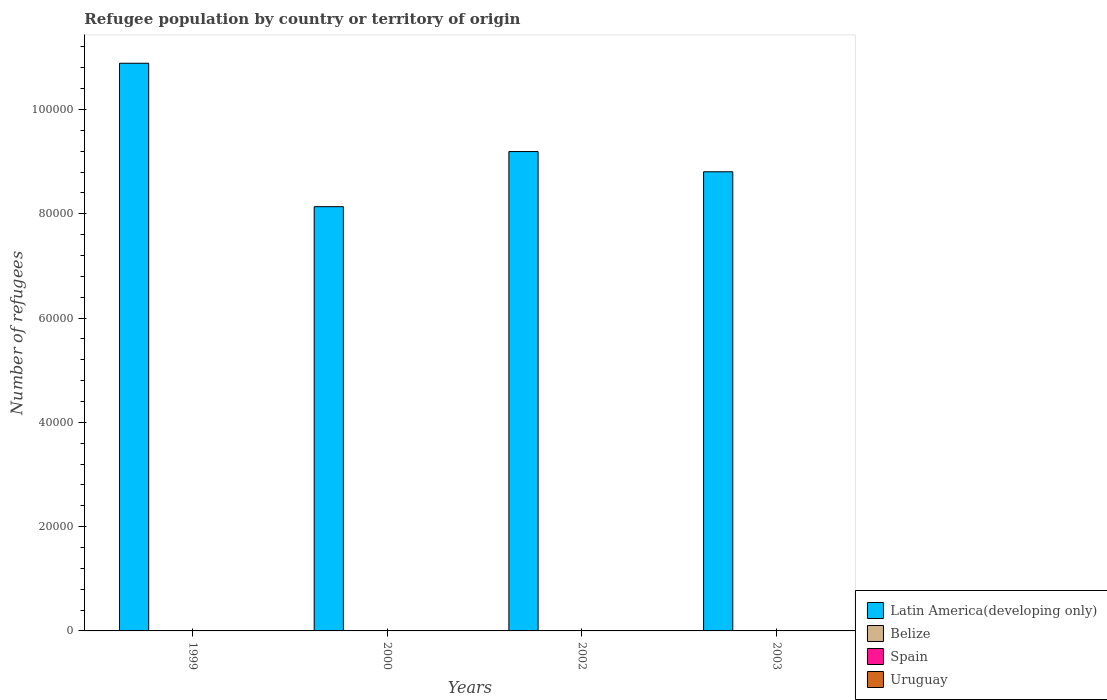Are the number of bars on each tick of the X-axis equal?
Give a very brief answer. Yes. How many bars are there on the 3rd tick from the left?
Your response must be concise. 4. How many bars are there on the 3rd tick from the right?
Your answer should be compact. 4. What is the number of refugees in Spain in 2002?
Provide a succinct answer. 58. Across all years, what is the minimum number of refugees in Latin America(developing only)?
Offer a terse response. 8.14e+04. In which year was the number of refugees in Uruguay maximum?
Your response must be concise. 2002. What is the total number of refugees in Uruguay in the graph?
Give a very brief answer. 208. What is the difference between the number of refugees in Belize in 1999 and that in 2003?
Your answer should be compact. 1. What is the difference between the number of refugees in Uruguay in 2003 and the number of refugees in Latin America(developing only) in 1999?
Offer a very short reply. -1.09e+05. What is the average number of refugees in Latin America(developing only) per year?
Provide a short and direct response. 9.26e+04. In how many years, is the number of refugees in Belize greater than 32000?
Provide a short and direct response. 0. What is the ratio of the number of refugees in Spain in 2000 to that in 2002?
Keep it short and to the point. 1.38. Is the number of refugees in Spain in 2002 less than that in 2003?
Keep it short and to the point. No. What is the difference between the highest and the second highest number of refugees in Spain?
Your answer should be very brief. 22. Is the sum of the number of refugees in Spain in 2002 and 2003 greater than the maximum number of refugees in Uruguay across all years?
Your answer should be very brief. Yes. Is it the case that in every year, the sum of the number of refugees in Spain and number of refugees in Uruguay is greater than the sum of number of refugees in Latin America(developing only) and number of refugees in Belize?
Ensure brevity in your answer.  Yes. What does the 1st bar from the left in 2003 represents?
Provide a succinct answer. Latin America(developing only). What does the 1st bar from the right in 2003 represents?
Provide a succinct answer. Uruguay. How many bars are there?
Offer a terse response. 16. How many years are there in the graph?
Offer a very short reply. 4. What is the difference between two consecutive major ticks on the Y-axis?
Keep it short and to the point. 2.00e+04. Where does the legend appear in the graph?
Give a very brief answer. Bottom right. What is the title of the graph?
Provide a succinct answer. Refugee population by country or territory of origin. Does "High income: OECD" appear as one of the legend labels in the graph?
Your answer should be very brief. No. What is the label or title of the X-axis?
Provide a short and direct response. Years. What is the label or title of the Y-axis?
Keep it short and to the point. Number of refugees. What is the Number of refugees in Latin America(developing only) in 1999?
Offer a very short reply. 1.09e+05. What is the Number of refugees of Latin America(developing only) in 2000?
Keep it short and to the point. 8.14e+04. What is the Number of refugees in Belize in 2000?
Make the answer very short. 12. What is the Number of refugees in Spain in 2000?
Your response must be concise. 80. What is the Number of refugees in Latin America(developing only) in 2002?
Ensure brevity in your answer.  9.19e+04. What is the Number of refugees of Latin America(developing only) in 2003?
Your answer should be very brief. 8.81e+04. What is the Number of refugees in Belize in 2003?
Offer a terse response. 10. What is the Number of refugees of Uruguay in 2003?
Ensure brevity in your answer.  57. Across all years, what is the maximum Number of refugees in Latin America(developing only)?
Offer a very short reply. 1.09e+05. Across all years, what is the maximum Number of refugees in Spain?
Provide a short and direct response. 80. Across all years, what is the maximum Number of refugees in Uruguay?
Give a very brief answer. 61. Across all years, what is the minimum Number of refugees in Latin America(developing only)?
Give a very brief answer. 8.14e+04. Across all years, what is the minimum Number of refugees in Belize?
Your answer should be very brief. 1. Across all years, what is the minimum Number of refugees in Spain?
Offer a very short reply. 53. What is the total Number of refugees of Latin America(developing only) in the graph?
Offer a very short reply. 3.70e+05. What is the total Number of refugees of Belize in the graph?
Provide a short and direct response. 34. What is the total Number of refugees of Spain in the graph?
Offer a very short reply. 244. What is the total Number of refugees of Uruguay in the graph?
Ensure brevity in your answer.  208. What is the difference between the Number of refugees in Latin America(developing only) in 1999 and that in 2000?
Provide a short and direct response. 2.75e+04. What is the difference between the Number of refugees in Belize in 1999 and that in 2000?
Give a very brief answer. -1. What is the difference between the Number of refugees in Uruguay in 1999 and that in 2000?
Offer a terse response. -12. What is the difference between the Number of refugees in Latin America(developing only) in 1999 and that in 2002?
Provide a short and direct response. 1.69e+04. What is the difference between the Number of refugees in Uruguay in 1999 and that in 2002?
Your answer should be very brief. -22. What is the difference between the Number of refugees of Latin America(developing only) in 1999 and that in 2003?
Your answer should be very brief. 2.08e+04. What is the difference between the Number of refugees in Latin America(developing only) in 2000 and that in 2002?
Make the answer very short. -1.06e+04. What is the difference between the Number of refugees of Spain in 2000 and that in 2002?
Your answer should be compact. 22. What is the difference between the Number of refugees in Latin America(developing only) in 2000 and that in 2003?
Provide a short and direct response. -6695. What is the difference between the Number of refugees of Belize in 2000 and that in 2003?
Your answer should be very brief. 2. What is the difference between the Number of refugees of Spain in 2000 and that in 2003?
Provide a succinct answer. 27. What is the difference between the Number of refugees in Latin America(developing only) in 2002 and that in 2003?
Make the answer very short. 3878. What is the difference between the Number of refugees of Belize in 2002 and that in 2003?
Your answer should be compact. -9. What is the difference between the Number of refugees in Uruguay in 2002 and that in 2003?
Your response must be concise. 4. What is the difference between the Number of refugees of Latin America(developing only) in 1999 and the Number of refugees of Belize in 2000?
Your response must be concise. 1.09e+05. What is the difference between the Number of refugees in Latin America(developing only) in 1999 and the Number of refugees in Spain in 2000?
Your answer should be compact. 1.09e+05. What is the difference between the Number of refugees in Latin America(developing only) in 1999 and the Number of refugees in Uruguay in 2000?
Ensure brevity in your answer.  1.09e+05. What is the difference between the Number of refugees of Belize in 1999 and the Number of refugees of Spain in 2000?
Offer a very short reply. -69. What is the difference between the Number of refugees in Spain in 1999 and the Number of refugees in Uruguay in 2000?
Offer a very short reply. 2. What is the difference between the Number of refugees of Latin America(developing only) in 1999 and the Number of refugees of Belize in 2002?
Your answer should be compact. 1.09e+05. What is the difference between the Number of refugees in Latin America(developing only) in 1999 and the Number of refugees in Spain in 2002?
Ensure brevity in your answer.  1.09e+05. What is the difference between the Number of refugees in Latin America(developing only) in 1999 and the Number of refugees in Uruguay in 2002?
Ensure brevity in your answer.  1.09e+05. What is the difference between the Number of refugees of Belize in 1999 and the Number of refugees of Spain in 2002?
Give a very brief answer. -47. What is the difference between the Number of refugees in Belize in 1999 and the Number of refugees in Uruguay in 2002?
Your answer should be compact. -50. What is the difference between the Number of refugees in Spain in 1999 and the Number of refugees in Uruguay in 2002?
Your answer should be compact. -8. What is the difference between the Number of refugees in Latin America(developing only) in 1999 and the Number of refugees in Belize in 2003?
Your answer should be compact. 1.09e+05. What is the difference between the Number of refugees in Latin America(developing only) in 1999 and the Number of refugees in Spain in 2003?
Provide a succinct answer. 1.09e+05. What is the difference between the Number of refugees of Latin America(developing only) in 1999 and the Number of refugees of Uruguay in 2003?
Your answer should be very brief. 1.09e+05. What is the difference between the Number of refugees of Belize in 1999 and the Number of refugees of Spain in 2003?
Your answer should be very brief. -42. What is the difference between the Number of refugees in Belize in 1999 and the Number of refugees in Uruguay in 2003?
Keep it short and to the point. -46. What is the difference between the Number of refugees of Spain in 1999 and the Number of refugees of Uruguay in 2003?
Your answer should be very brief. -4. What is the difference between the Number of refugees of Latin America(developing only) in 2000 and the Number of refugees of Belize in 2002?
Provide a short and direct response. 8.14e+04. What is the difference between the Number of refugees of Latin America(developing only) in 2000 and the Number of refugees of Spain in 2002?
Your answer should be compact. 8.13e+04. What is the difference between the Number of refugees in Latin America(developing only) in 2000 and the Number of refugees in Uruguay in 2002?
Your answer should be very brief. 8.13e+04. What is the difference between the Number of refugees of Belize in 2000 and the Number of refugees of Spain in 2002?
Offer a terse response. -46. What is the difference between the Number of refugees of Belize in 2000 and the Number of refugees of Uruguay in 2002?
Ensure brevity in your answer.  -49. What is the difference between the Number of refugees of Spain in 2000 and the Number of refugees of Uruguay in 2002?
Offer a very short reply. 19. What is the difference between the Number of refugees of Latin America(developing only) in 2000 and the Number of refugees of Belize in 2003?
Your response must be concise. 8.14e+04. What is the difference between the Number of refugees in Latin America(developing only) in 2000 and the Number of refugees in Spain in 2003?
Give a very brief answer. 8.13e+04. What is the difference between the Number of refugees in Latin America(developing only) in 2000 and the Number of refugees in Uruguay in 2003?
Keep it short and to the point. 8.13e+04. What is the difference between the Number of refugees in Belize in 2000 and the Number of refugees in Spain in 2003?
Ensure brevity in your answer.  -41. What is the difference between the Number of refugees of Belize in 2000 and the Number of refugees of Uruguay in 2003?
Make the answer very short. -45. What is the difference between the Number of refugees in Latin America(developing only) in 2002 and the Number of refugees in Belize in 2003?
Your answer should be compact. 9.19e+04. What is the difference between the Number of refugees in Latin America(developing only) in 2002 and the Number of refugees in Spain in 2003?
Your answer should be very brief. 9.19e+04. What is the difference between the Number of refugees in Latin America(developing only) in 2002 and the Number of refugees in Uruguay in 2003?
Provide a short and direct response. 9.19e+04. What is the difference between the Number of refugees of Belize in 2002 and the Number of refugees of Spain in 2003?
Keep it short and to the point. -52. What is the difference between the Number of refugees in Belize in 2002 and the Number of refugees in Uruguay in 2003?
Your response must be concise. -56. What is the difference between the Number of refugees of Spain in 2002 and the Number of refugees of Uruguay in 2003?
Provide a succinct answer. 1. What is the average Number of refugees of Latin America(developing only) per year?
Give a very brief answer. 9.26e+04. What is the average Number of refugees of Spain per year?
Provide a short and direct response. 61. In the year 1999, what is the difference between the Number of refugees of Latin America(developing only) and Number of refugees of Belize?
Your response must be concise. 1.09e+05. In the year 1999, what is the difference between the Number of refugees of Latin America(developing only) and Number of refugees of Spain?
Make the answer very short. 1.09e+05. In the year 1999, what is the difference between the Number of refugees of Latin America(developing only) and Number of refugees of Uruguay?
Provide a succinct answer. 1.09e+05. In the year 1999, what is the difference between the Number of refugees in Belize and Number of refugees in Spain?
Give a very brief answer. -42. In the year 1999, what is the difference between the Number of refugees in Belize and Number of refugees in Uruguay?
Your response must be concise. -28. In the year 2000, what is the difference between the Number of refugees in Latin America(developing only) and Number of refugees in Belize?
Keep it short and to the point. 8.14e+04. In the year 2000, what is the difference between the Number of refugees of Latin America(developing only) and Number of refugees of Spain?
Provide a succinct answer. 8.13e+04. In the year 2000, what is the difference between the Number of refugees of Latin America(developing only) and Number of refugees of Uruguay?
Make the answer very short. 8.13e+04. In the year 2000, what is the difference between the Number of refugees in Belize and Number of refugees in Spain?
Keep it short and to the point. -68. In the year 2000, what is the difference between the Number of refugees in Belize and Number of refugees in Uruguay?
Your answer should be very brief. -39. In the year 2000, what is the difference between the Number of refugees in Spain and Number of refugees in Uruguay?
Offer a terse response. 29. In the year 2002, what is the difference between the Number of refugees of Latin America(developing only) and Number of refugees of Belize?
Your answer should be very brief. 9.19e+04. In the year 2002, what is the difference between the Number of refugees in Latin America(developing only) and Number of refugees in Spain?
Make the answer very short. 9.19e+04. In the year 2002, what is the difference between the Number of refugees of Latin America(developing only) and Number of refugees of Uruguay?
Your answer should be very brief. 9.19e+04. In the year 2002, what is the difference between the Number of refugees in Belize and Number of refugees in Spain?
Provide a short and direct response. -57. In the year 2002, what is the difference between the Number of refugees in Belize and Number of refugees in Uruguay?
Give a very brief answer. -60. In the year 2002, what is the difference between the Number of refugees of Spain and Number of refugees of Uruguay?
Your answer should be very brief. -3. In the year 2003, what is the difference between the Number of refugees of Latin America(developing only) and Number of refugees of Belize?
Keep it short and to the point. 8.80e+04. In the year 2003, what is the difference between the Number of refugees in Latin America(developing only) and Number of refugees in Spain?
Ensure brevity in your answer.  8.80e+04. In the year 2003, what is the difference between the Number of refugees of Latin America(developing only) and Number of refugees of Uruguay?
Keep it short and to the point. 8.80e+04. In the year 2003, what is the difference between the Number of refugees in Belize and Number of refugees in Spain?
Keep it short and to the point. -43. In the year 2003, what is the difference between the Number of refugees in Belize and Number of refugees in Uruguay?
Keep it short and to the point. -47. What is the ratio of the Number of refugees in Latin America(developing only) in 1999 to that in 2000?
Make the answer very short. 1.34. What is the ratio of the Number of refugees of Belize in 1999 to that in 2000?
Offer a very short reply. 0.92. What is the ratio of the Number of refugees of Spain in 1999 to that in 2000?
Your answer should be compact. 0.66. What is the ratio of the Number of refugees of Uruguay in 1999 to that in 2000?
Keep it short and to the point. 0.76. What is the ratio of the Number of refugees in Latin America(developing only) in 1999 to that in 2002?
Provide a succinct answer. 1.18. What is the ratio of the Number of refugees in Belize in 1999 to that in 2002?
Keep it short and to the point. 11. What is the ratio of the Number of refugees in Spain in 1999 to that in 2002?
Give a very brief answer. 0.91. What is the ratio of the Number of refugees of Uruguay in 1999 to that in 2002?
Keep it short and to the point. 0.64. What is the ratio of the Number of refugees of Latin America(developing only) in 1999 to that in 2003?
Provide a succinct answer. 1.24. What is the ratio of the Number of refugees of Belize in 1999 to that in 2003?
Provide a short and direct response. 1.1. What is the ratio of the Number of refugees in Uruguay in 1999 to that in 2003?
Provide a succinct answer. 0.68. What is the ratio of the Number of refugees in Latin America(developing only) in 2000 to that in 2002?
Your answer should be very brief. 0.89. What is the ratio of the Number of refugees in Belize in 2000 to that in 2002?
Your answer should be compact. 12. What is the ratio of the Number of refugees of Spain in 2000 to that in 2002?
Make the answer very short. 1.38. What is the ratio of the Number of refugees in Uruguay in 2000 to that in 2002?
Offer a terse response. 0.84. What is the ratio of the Number of refugees of Latin America(developing only) in 2000 to that in 2003?
Keep it short and to the point. 0.92. What is the ratio of the Number of refugees of Belize in 2000 to that in 2003?
Provide a succinct answer. 1.2. What is the ratio of the Number of refugees in Spain in 2000 to that in 2003?
Provide a short and direct response. 1.51. What is the ratio of the Number of refugees in Uruguay in 2000 to that in 2003?
Offer a terse response. 0.89. What is the ratio of the Number of refugees in Latin America(developing only) in 2002 to that in 2003?
Ensure brevity in your answer.  1.04. What is the ratio of the Number of refugees in Belize in 2002 to that in 2003?
Provide a succinct answer. 0.1. What is the ratio of the Number of refugees in Spain in 2002 to that in 2003?
Ensure brevity in your answer.  1.09. What is the ratio of the Number of refugees in Uruguay in 2002 to that in 2003?
Offer a terse response. 1.07. What is the difference between the highest and the second highest Number of refugees in Latin America(developing only)?
Provide a succinct answer. 1.69e+04. What is the difference between the highest and the second highest Number of refugees of Spain?
Ensure brevity in your answer.  22. What is the difference between the highest and the lowest Number of refugees of Latin America(developing only)?
Ensure brevity in your answer.  2.75e+04. What is the difference between the highest and the lowest Number of refugees of Belize?
Your answer should be very brief. 11. What is the difference between the highest and the lowest Number of refugees of Spain?
Provide a short and direct response. 27. What is the difference between the highest and the lowest Number of refugees of Uruguay?
Offer a terse response. 22. 